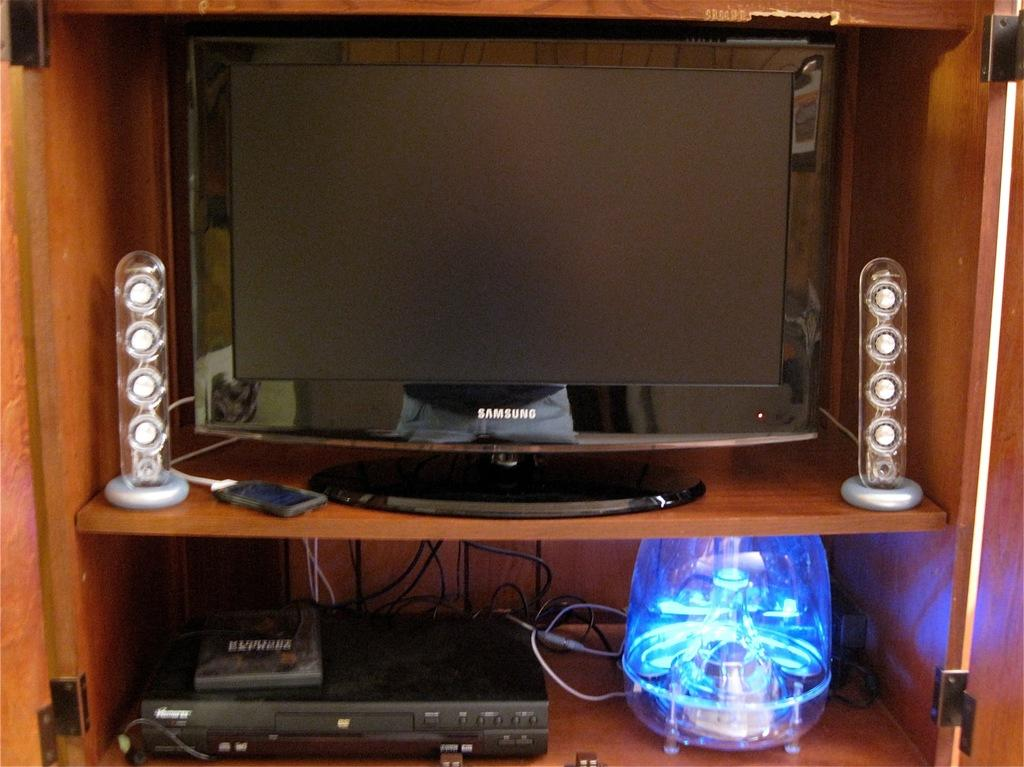<image>
Present a compact description of the photo's key features. A Samsung TV on the shelf of a wooden entertainment center. 